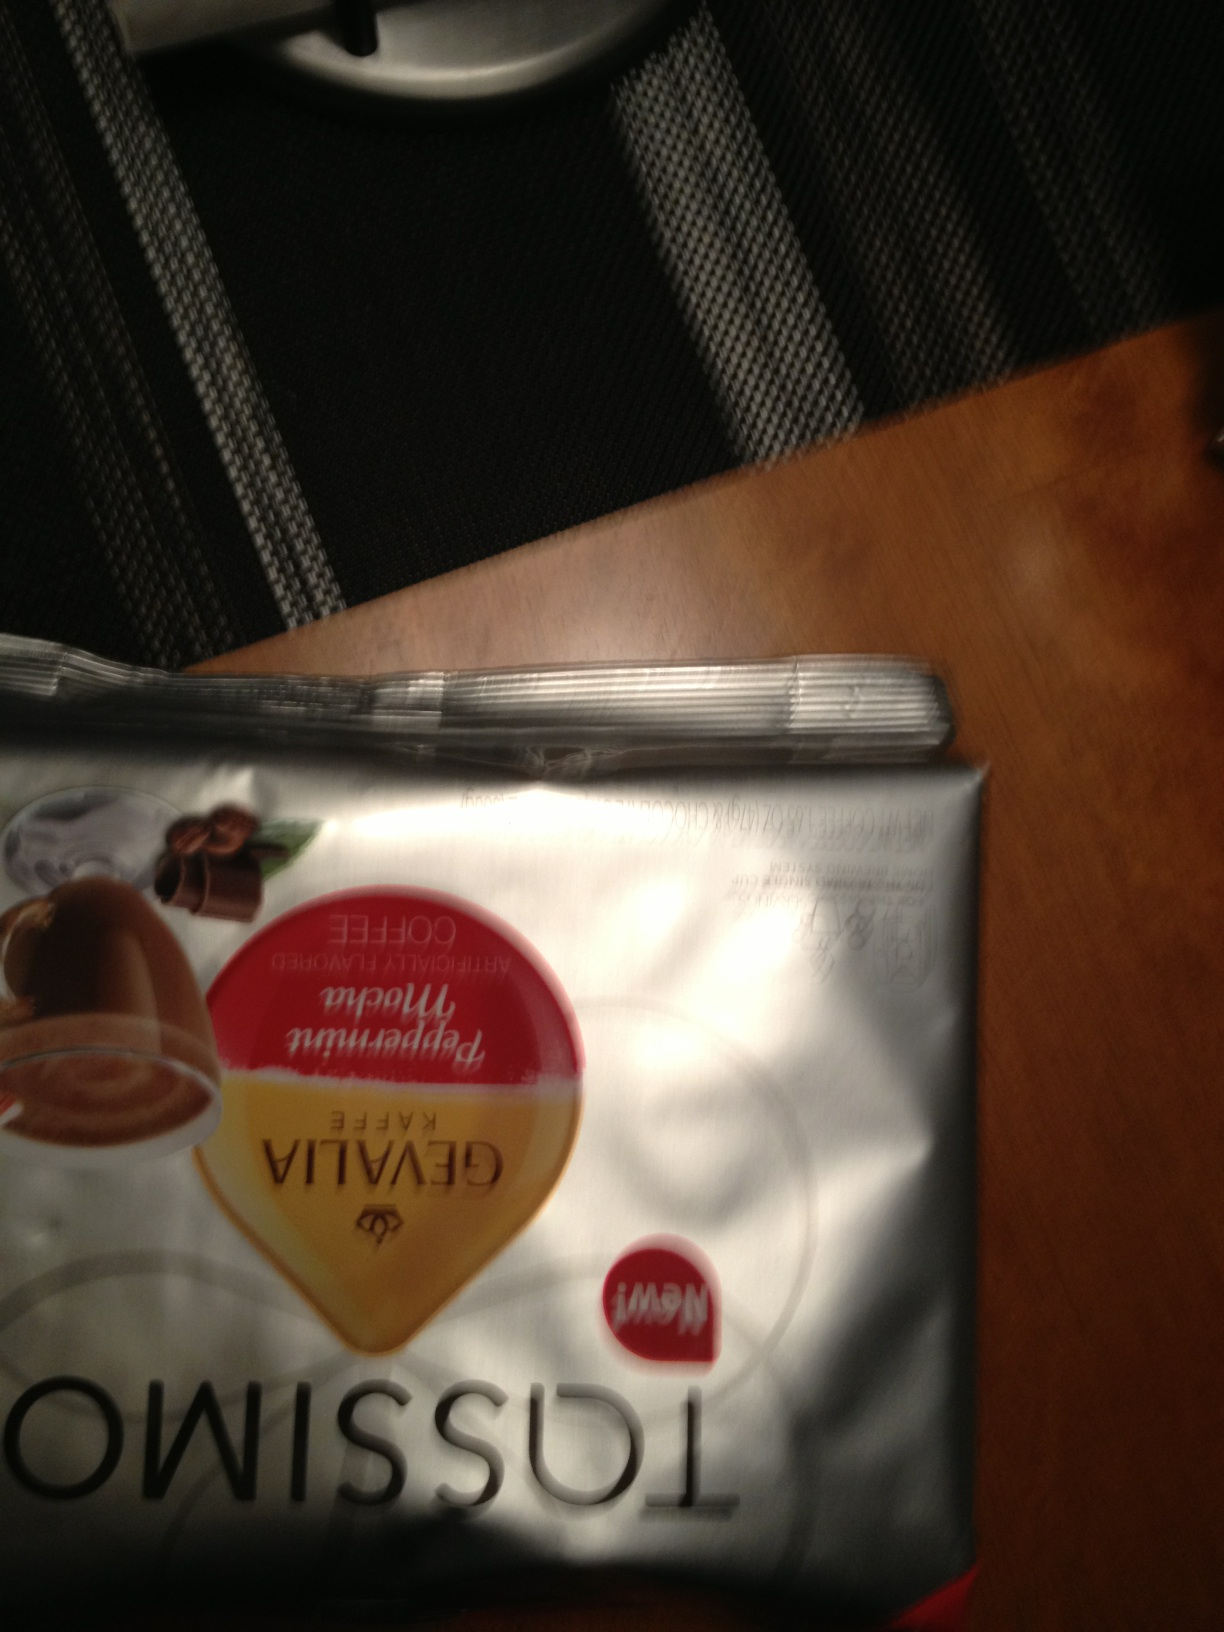Can you suggest the best way to prepare this coffee? Certainly! Gevalia coffee is best enjoyed when freshly brewed. For this particular blend, using a coffee maker or brewing a single cup with a pour-over method will enhance its flavor profile. Ensure you use filtered water at the right temperature (around 195°F to 205°F) for the best taste. Grinding the beans just before brewing also helps retain the coffee's full-bodied flavor and aroma. 